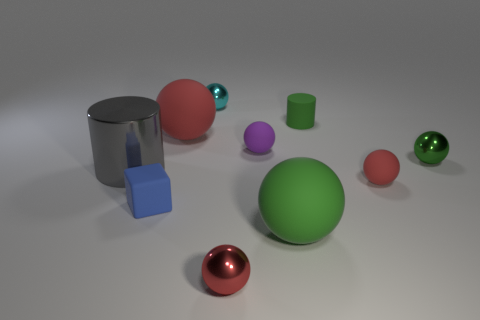Is there a pattern to the arrangement of the objects in the image? The objects don't seem to follow a strict pattern. However, the arrangement does provide a harmonious visual balance, with a mix of spheres and cylinders of varying sizes and colors tastefully positioned to create a pleasing and somewhat symmetrical composition. 